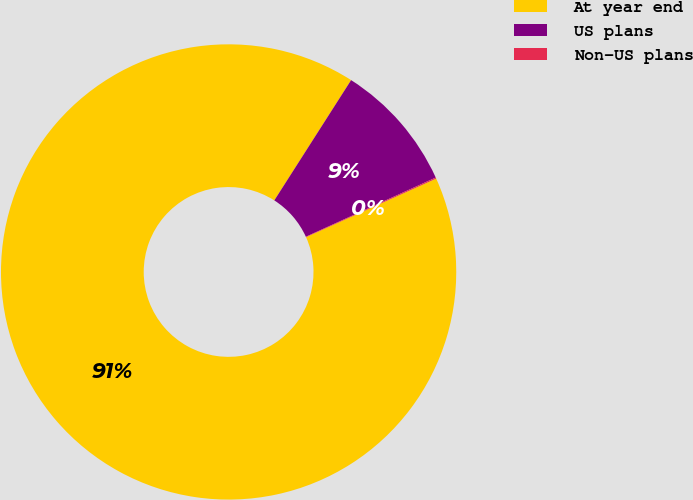Convert chart to OTSL. <chart><loc_0><loc_0><loc_500><loc_500><pie_chart><fcel>At year end<fcel>US plans<fcel>Non-US plans<nl><fcel>90.78%<fcel>9.15%<fcel>0.08%<nl></chart> 